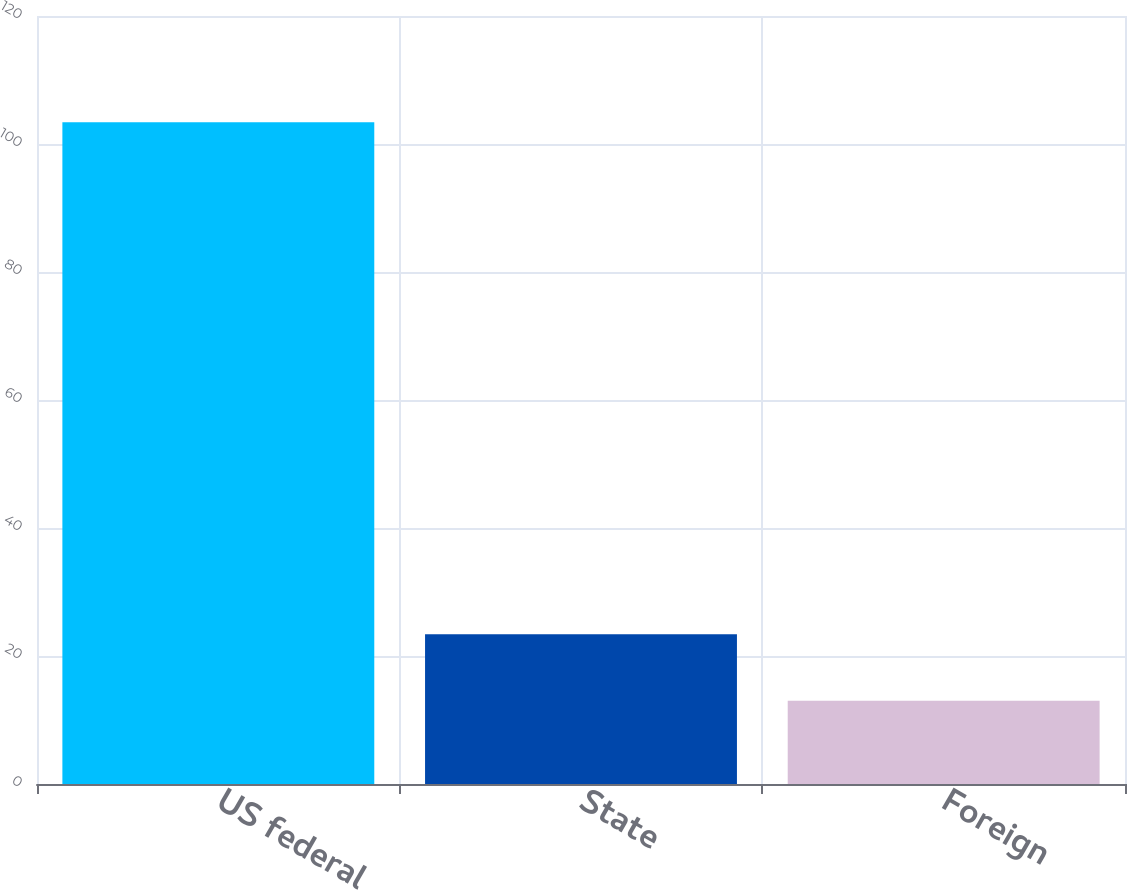<chart> <loc_0><loc_0><loc_500><loc_500><bar_chart><fcel>US federal<fcel>State<fcel>Foreign<nl><fcel>103.4<fcel>23.4<fcel>13<nl></chart> 